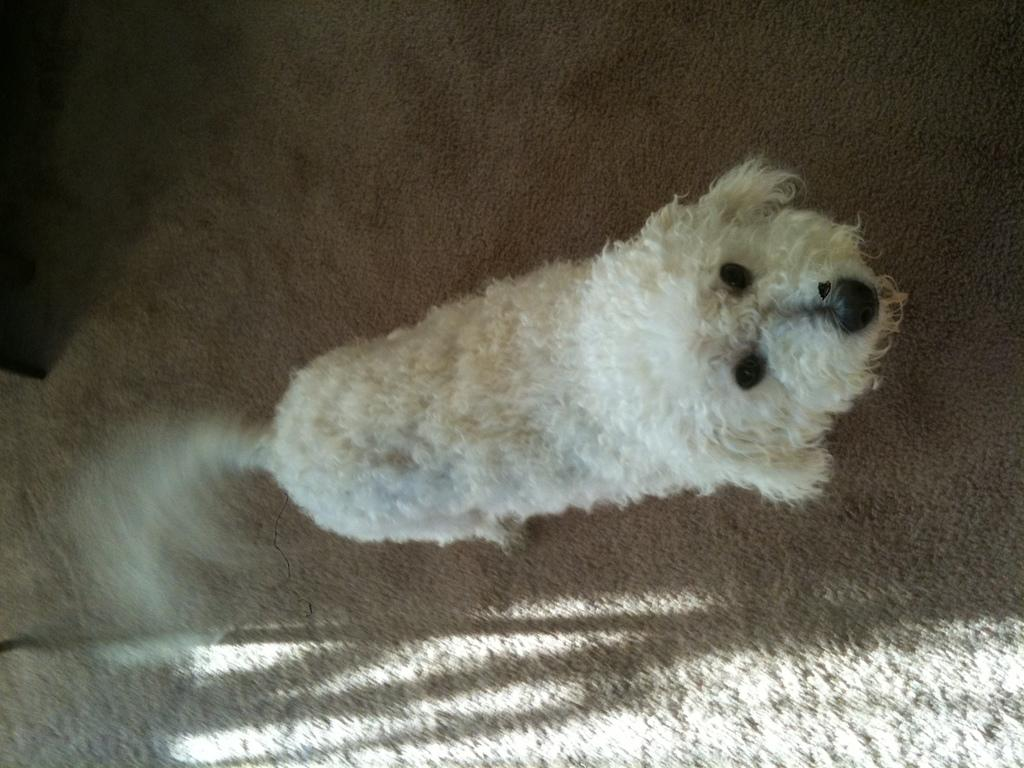What type of animal is in the image? There is a dog in the image. What is the dog standing on? The dog is standing on a mat. What type of love is the dog expressing in the image? The image does not mention or depict any specific type of love; it only shows a dog standing on a mat. 